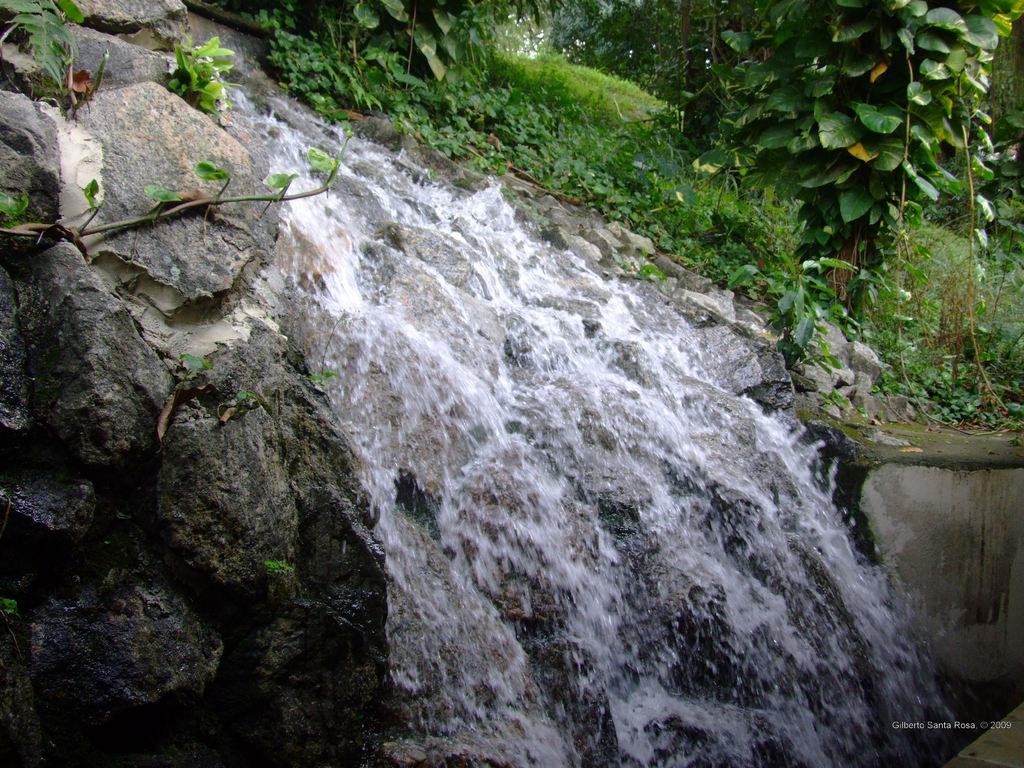What is the main feature in the center of the image? There is a waterfall in the center of the image. What type of natural elements can be seen in the image? There are rocks, grass, plants, and trees in the image. Where are the trees located in the image? The trees are at the top of the image. What type of prison can be seen in the image? There is no prison present in the image; it features a waterfall and natural elements. How does the queen interact with the wind in the image? There is no queen or wind present in the image. 